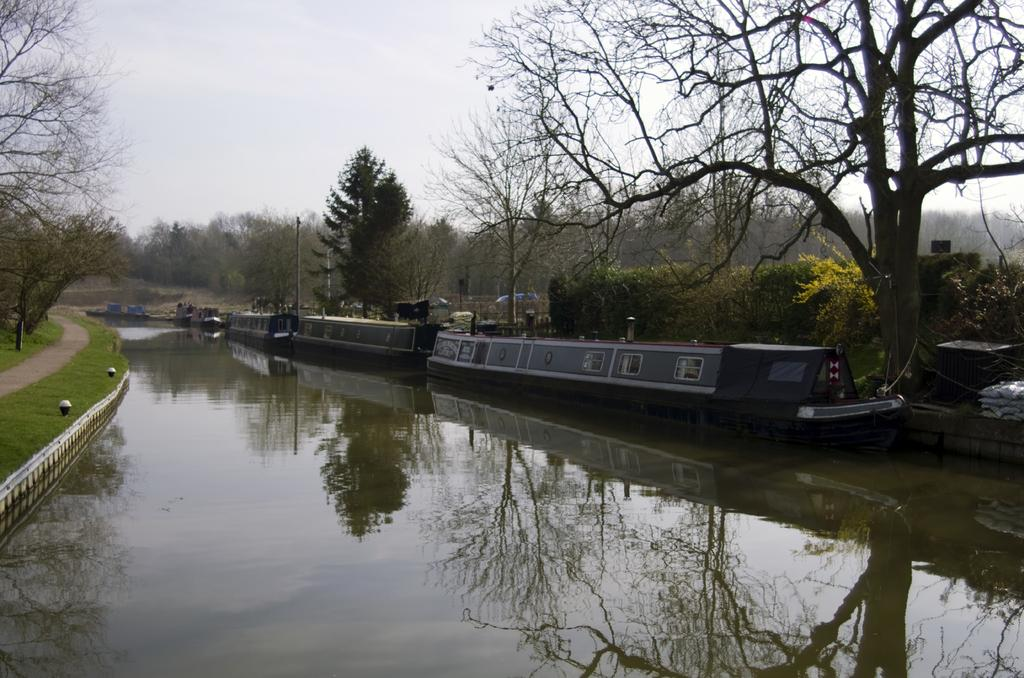What is the primary element present in the image? There is water in the image. What else can be seen in the image besides the water? There is a vehicle and the background includes trees in green color and poles. What is the color of the sky in the image? The sky is visible in the image and appears to be white. What type of loss is being experienced by the trees in the image? There is no indication of loss in the image; the trees are simply present in the background. 